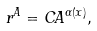Convert formula to latex. <formula><loc_0><loc_0><loc_500><loc_500>r ^ { A } = C A ^ { \alpha ( x ) } ,</formula> 